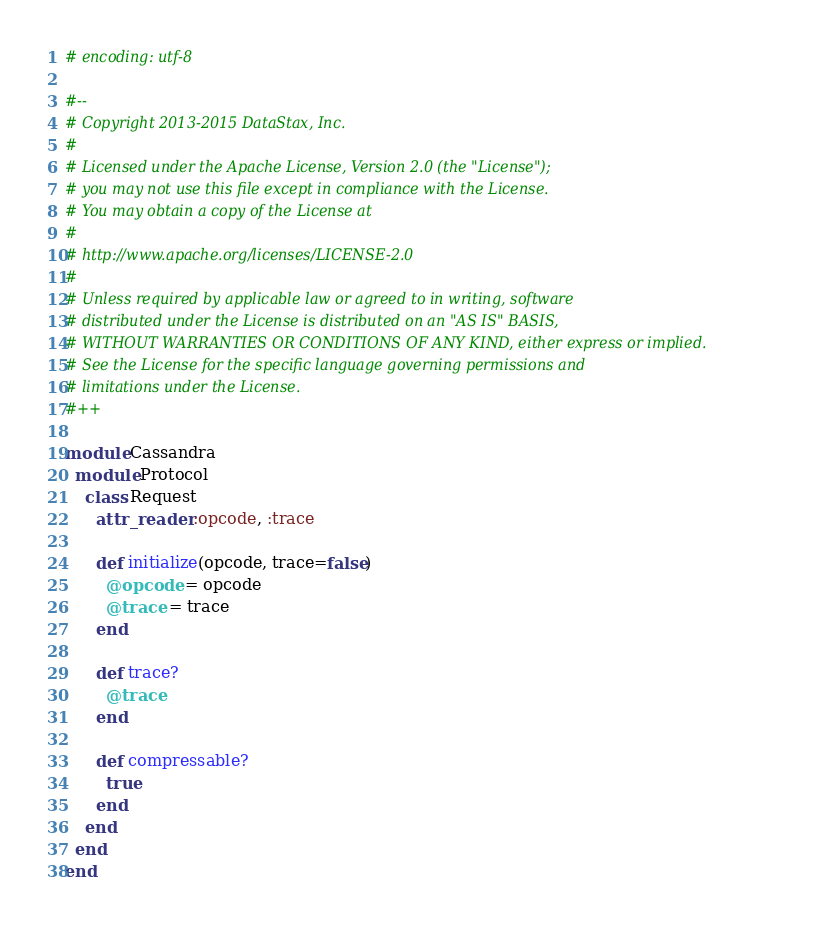Convert code to text. <code><loc_0><loc_0><loc_500><loc_500><_Ruby_># encoding: utf-8

#--
# Copyright 2013-2015 DataStax, Inc.
#
# Licensed under the Apache License, Version 2.0 (the "License");
# you may not use this file except in compliance with the License.
# You may obtain a copy of the License at
#
# http://www.apache.org/licenses/LICENSE-2.0
#
# Unless required by applicable law or agreed to in writing, software
# distributed under the License is distributed on an "AS IS" BASIS,
# WITHOUT WARRANTIES OR CONDITIONS OF ANY KIND, either express or implied.
# See the License for the specific language governing permissions and
# limitations under the License.
#++

module Cassandra
  module Protocol
    class Request
      attr_reader :opcode, :trace

      def initialize(opcode, trace=false)
        @opcode = opcode
        @trace = trace
      end

      def trace?
        @trace
      end

      def compressable?
        true
      end
    end
  end
end
</code> 